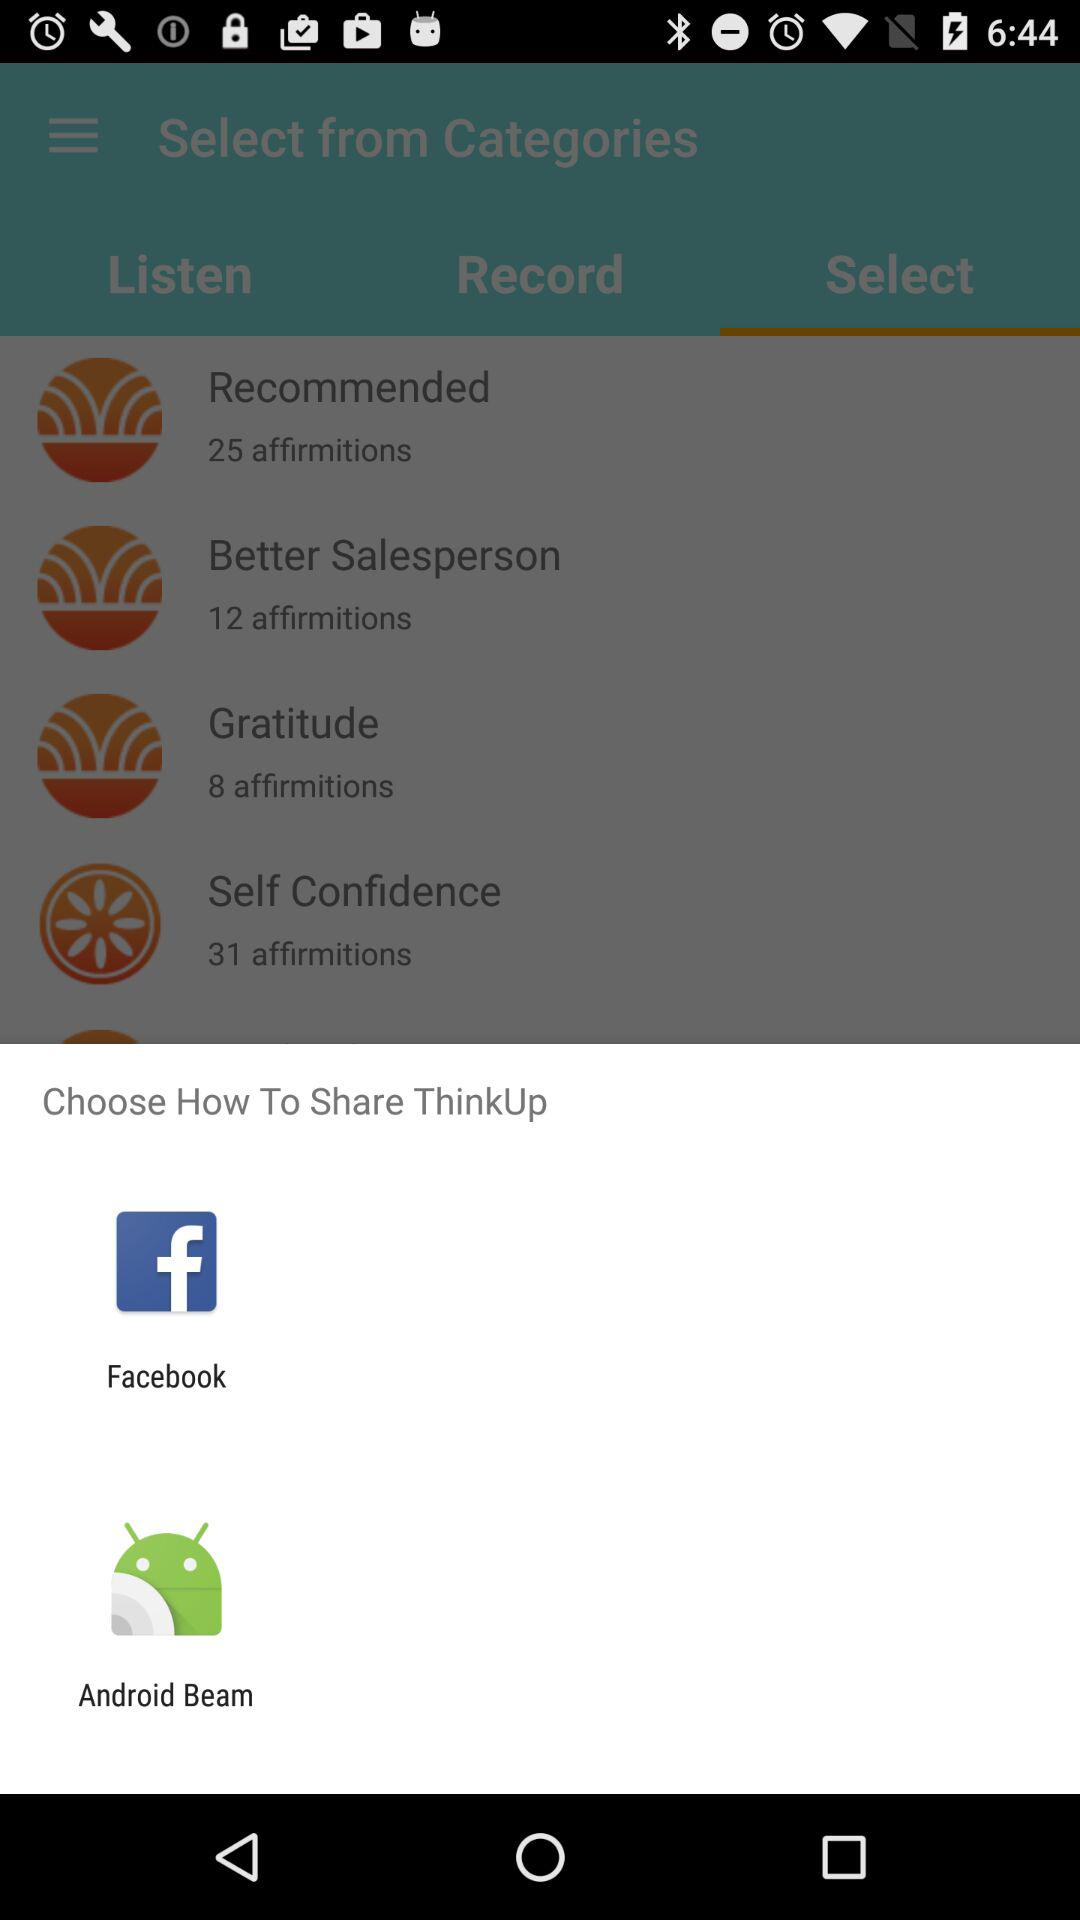Through which application can we share? You can share through "Facebook" and "Android Beam". 